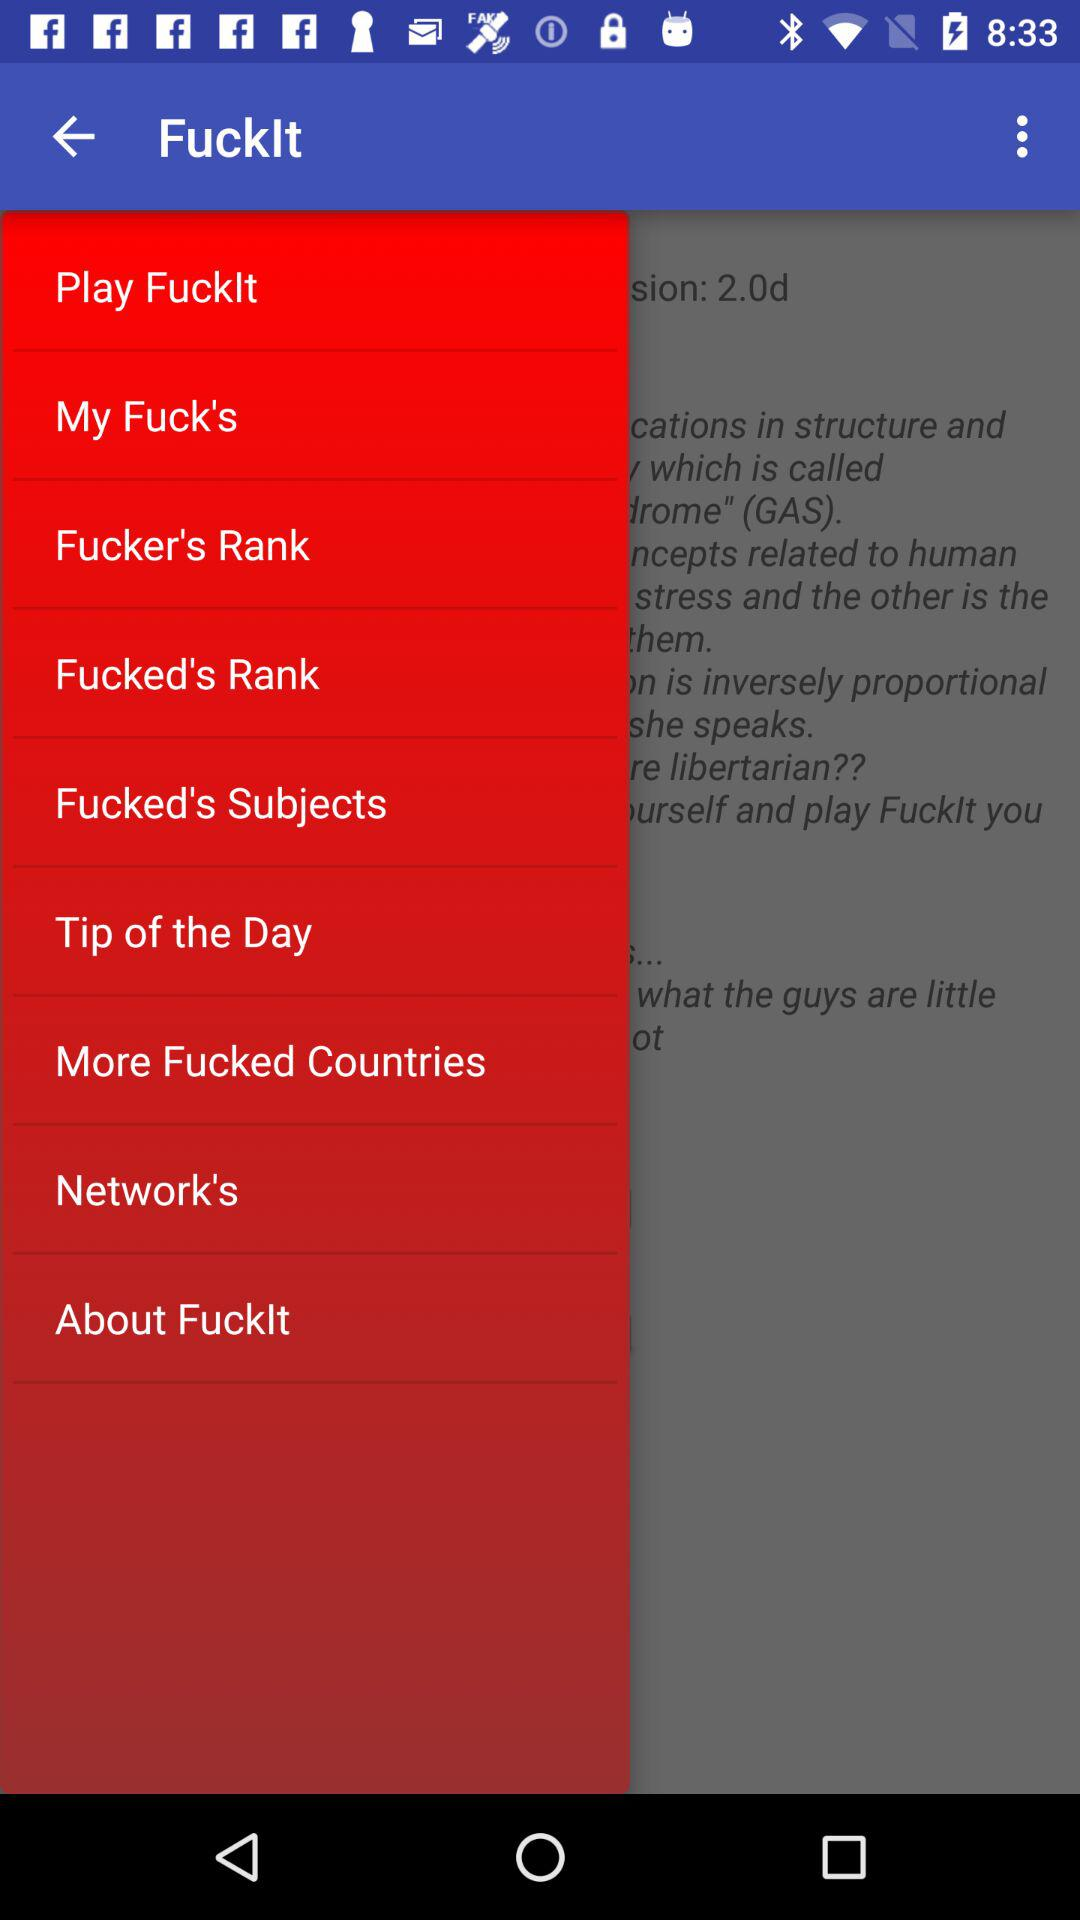What is the name of the application? The name of the application is "FuckIt". 